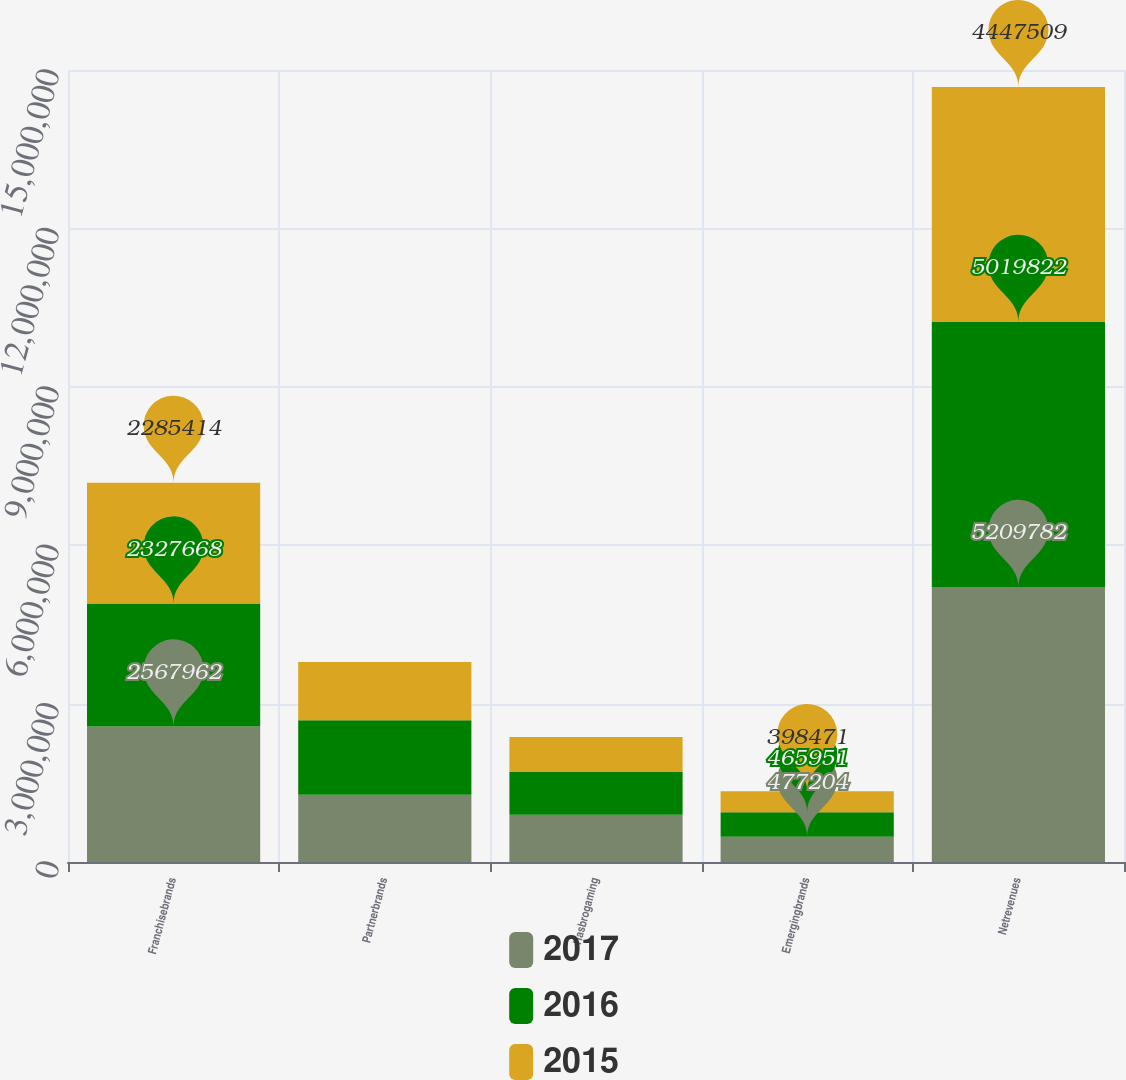Convert chart to OTSL. <chart><loc_0><loc_0><loc_500><loc_500><stacked_bar_chart><ecel><fcel>Franchisebrands<fcel>Partnerbrands<fcel>Hasbrogaming<fcel>Emergingbrands<fcel>Netrevenues<nl><fcel>2017<fcel>2.56796e+06<fcel>1.2716e+06<fcel>893019<fcel>477204<fcel>5.20978e+06<nl><fcel>2016<fcel>2.32767e+06<fcel>1.41277e+06<fcel>813433<fcel>465951<fcel>5.01982e+06<nl><fcel>2015<fcel>2.28541e+06<fcel>1.1013e+06<fcel>662319<fcel>398471<fcel>4.44751e+06<nl></chart> 